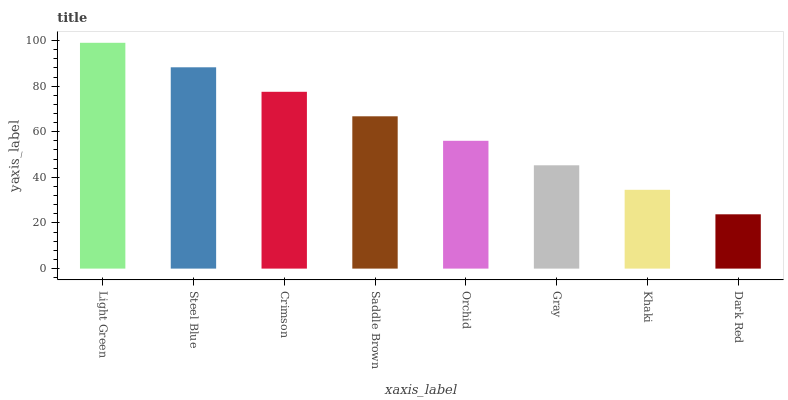Is Dark Red the minimum?
Answer yes or no. Yes. Is Light Green the maximum?
Answer yes or no. Yes. Is Steel Blue the minimum?
Answer yes or no. No. Is Steel Blue the maximum?
Answer yes or no. No. Is Light Green greater than Steel Blue?
Answer yes or no. Yes. Is Steel Blue less than Light Green?
Answer yes or no. Yes. Is Steel Blue greater than Light Green?
Answer yes or no. No. Is Light Green less than Steel Blue?
Answer yes or no. No. Is Saddle Brown the high median?
Answer yes or no. Yes. Is Orchid the low median?
Answer yes or no. Yes. Is Khaki the high median?
Answer yes or no. No. Is Khaki the low median?
Answer yes or no. No. 